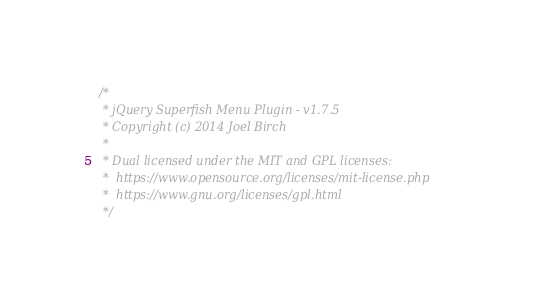<code> <loc_0><loc_0><loc_500><loc_500><_JavaScript_>/*
 * jQuery Superfish Menu Plugin - v1.7.5
 * Copyright (c) 2014 Joel Birch
 *
 * Dual licensed under the MIT and GPL licenses:
 *	https://www.opensource.org/licenses/mit-license.php
 *	https://www.gnu.org/licenses/gpl.html
 */
</code> 